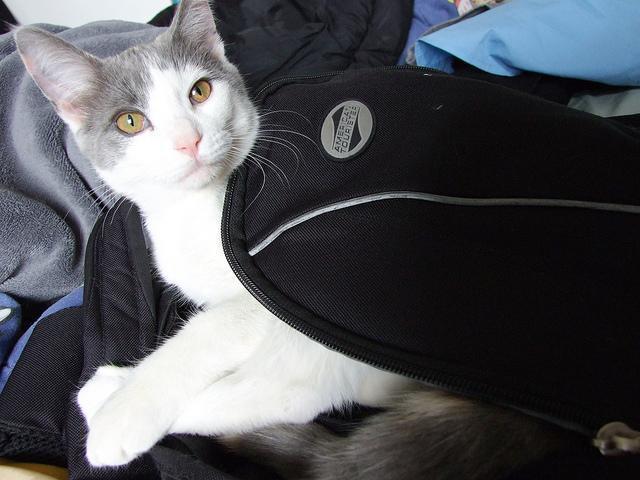How many chairs are there?
Give a very brief answer. 0. 